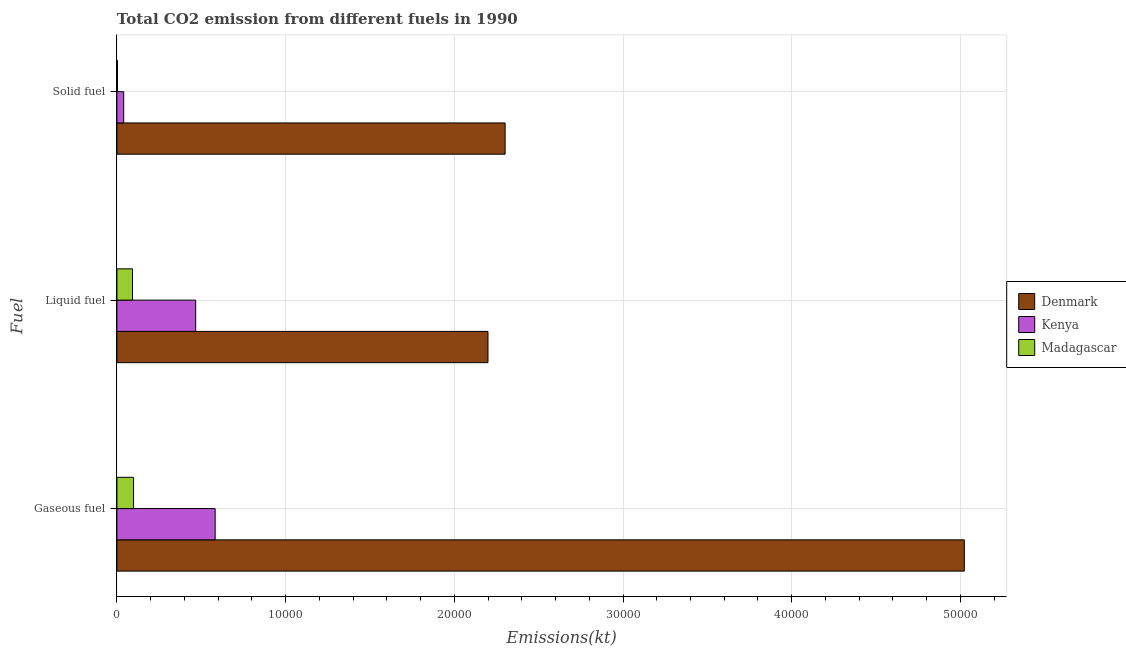How many groups of bars are there?
Your answer should be compact. 3. Are the number of bars on each tick of the Y-axis equal?
Give a very brief answer. Yes. How many bars are there on the 3rd tick from the top?
Your response must be concise. 3. What is the label of the 2nd group of bars from the top?
Make the answer very short. Liquid fuel. What is the amount of co2 emissions from liquid fuel in Madagascar?
Ensure brevity in your answer.  924.08. Across all countries, what is the maximum amount of co2 emissions from solid fuel?
Offer a very short reply. 2.30e+04. Across all countries, what is the minimum amount of co2 emissions from gaseous fuel?
Give a very brief answer. 986.42. In which country was the amount of co2 emissions from solid fuel maximum?
Your answer should be compact. Denmark. In which country was the amount of co2 emissions from solid fuel minimum?
Make the answer very short. Madagascar. What is the total amount of co2 emissions from solid fuel in the graph?
Make the answer very short. 2.34e+04. What is the difference between the amount of co2 emissions from solid fuel in Kenya and that in Denmark?
Provide a short and direct response. -2.26e+04. What is the difference between the amount of co2 emissions from liquid fuel in Madagascar and the amount of co2 emissions from gaseous fuel in Kenya?
Your answer should be very brief. -4899.11. What is the average amount of co2 emissions from gaseous fuel per country?
Your response must be concise. 1.90e+04. What is the difference between the amount of co2 emissions from solid fuel and amount of co2 emissions from liquid fuel in Denmark?
Ensure brevity in your answer.  1015.76. In how many countries, is the amount of co2 emissions from solid fuel greater than 40000 kt?
Your answer should be compact. 0. What is the ratio of the amount of co2 emissions from liquid fuel in Madagascar to that in Kenya?
Make the answer very short. 0.2. Is the amount of co2 emissions from liquid fuel in Madagascar less than that in Denmark?
Your answer should be very brief. Yes. What is the difference between the highest and the second highest amount of co2 emissions from gaseous fuel?
Your answer should be very brief. 4.44e+04. What is the difference between the highest and the lowest amount of co2 emissions from gaseous fuel?
Ensure brevity in your answer.  4.92e+04. What does the 2nd bar from the top in Liquid fuel represents?
Give a very brief answer. Kenya. What does the 2nd bar from the bottom in Liquid fuel represents?
Provide a succinct answer. Kenya. Is it the case that in every country, the sum of the amount of co2 emissions from gaseous fuel and amount of co2 emissions from liquid fuel is greater than the amount of co2 emissions from solid fuel?
Provide a succinct answer. Yes. Are the values on the major ticks of X-axis written in scientific E-notation?
Make the answer very short. No. Does the graph contain grids?
Your response must be concise. Yes. Where does the legend appear in the graph?
Ensure brevity in your answer.  Center right. How many legend labels are there?
Offer a very short reply. 3. What is the title of the graph?
Provide a short and direct response. Total CO2 emission from different fuels in 1990. What is the label or title of the X-axis?
Your answer should be very brief. Emissions(kt). What is the label or title of the Y-axis?
Offer a terse response. Fuel. What is the Emissions(kt) in Denmark in Gaseous fuel?
Your answer should be very brief. 5.02e+04. What is the Emissions(kt) in Kenya in Gaseous fuel?
Give a very brief answer. 5823.2. What is the Emissions(kt) in Madagascar in Gaseous fuel?
Offer a terse response. 986.42. What is the Emissions(kt) in Denmark in Liquid fuel?
Make the answer very short. 2.20e+04. What is the Emissions(kt) in Kenya in Liquid fuel?
Make the answer very short. 4668.09. What is the Emissions(kt) in Madagascar in Liquid fuel?
Make the answer very short. 924.08. What is the Emissions(kt) of Denmark in Solid fuel?
Offer a very short reply. 2.30e+04. What is the Emissions(kt) in Kenya in Solid fuel?
Offer a very short reply. 403.37. What is the Emissions(kt) in Madagascar in Solid fuel?
Provide a short and direct response. 33. Across all Fuel, what is the maximum Emissions(kt) in Denmark?
Keep it short and to the point. 5.02e+04. Across all Fuel, what is the maximum Emissions(kt) of Kenya?
Offer a very short reply. 5823.2. Across all Fuel, what is the maximum Emissions(kt) in Madagascar?
Your answer should be compact. 986.42. Across all Fuel, what is the minimum Emissions(kt) of Denmark?
Offer a terse response. 2.20e+04. Across all Fuel, what is the minimum Emissions(kt) of Kenya?
Your answer should be very brief. 403.37. Across all Fuel, what is the minimum Emissions(kt) of Madagascar?
Provide a short and direct response. 33. What is the total Emissions(kt) in Denmark in the graph?
Your answer should be compact. 9.52e+04. What is the total Emissions(kt) in Kenya in the graph?
Your answer should be very brief. 1.09e+04. What is the total Emissions(kt) of Madagascar in the graph?
Provide a short and direct response. 1943.51. What is the difference between the Emissions(kt) of Denmark in Gaseous fuel and that in Liquid fuel?
Your answer should be very brief. 2.82e+04. What is the difference between the Emissions(kt) in Kenya in Gaseous fuel and that in Liquid fuel?
Make the answer very short. 1155.11. What is the difference between the Emissions(kt) of Madagascar in Gaseous fuel and that in Liquid fuel?
Offer a terse response. 62.34. What is the difference between the Emissions(kt) of Denmark in Gaseous fuel and that in Solid fuel?
Offer a terse response. 2.72e+04. What is the difference between the Emissions(kt) in Kenya in Gaseous fuel and that in Solid fuel?
Keep it short and to the point. 5419.83. What is the difference between the Emissions(kt) in Madagascar in Gaseous fuel and that in Solid fuel?
Keep it short and to the point. 953.42. What is the difference between the Emissions(kt) of Denmark in Liquid fuel and that in Solid fuel?
Your answer should be very brief. -1015.76. What is the difference between the Emissions(kt) in Kenya in Liquid fuel and that in Solid fuel?
Make the answer very short. 4264.72. What is the difference between the Emissions(kt) in Madagascar in Liquid fuel and that in Solid fuel?
Your answer should be compact. 891.08. What is the difference between the Emissions(kt) of Denmark in Gaseous fuel and the Emissions(kt) of Kenya in Liquid fuel?
Give a very brief answer. 4.56e+04. What is the difference between the Emissions(kt) of Denmark in Gaseous fuel and the Emissions(kt) of Madagascar in Liquid fuel?
Ensure brevity in your answer.  4.93e+04. What is the difference between the Emissions(kt) of Kenya in Gaseous fuel and the Emissions(kt) of Madagascar in Liquid fuel?
Give a very brief answer. 4899.11. What is the difference between the Emissions(kt) of Denmark in Gaseous fuel and the Emissions(kt) of Kenya in Solid fuel?
Your response must be concise. 4.98e+04. What is the difference between the Emissions(kt) of Denmark in Gaseous fuel and the Emissions(kt) of Madagascar in Solid fuel?
Your response must be concise. 5.02e+04. What is the difference between the Emissions(kt) of Kenya in Gaseous fuel and the Emissions(kt) of Madagascar in Solid fuel?
Give a very brief answer. 5790.19. What is the difference between the Emissions(kt) in Denmark in Liquid fuel and the Emissions(kt) in Kenya in Solid fuel?
Your answer should be very brief. 2.16e+04. What is the difference between the Emissions(kt) of Denmark in Liquid fuel and the Emissions(kt) of Madagascar in Solid fuel?
Your answer should be compact. 2.20e+04. What is the difference between the Emissions(kt) in Kenya in Liquid fuel and the Emissions(kt) in Madagascar in Solid fuel?
Offer a very short reply. 4635.09. What is the average Emissions(kt) in Denmark per Fuel?
Your answer should be very brief. 3.17e+04. What is the average Emissions(kt) in Kenya per Fuel?
Your answer should be very brief. 3631.55. What is the average Emissions(kt) of Madagascar per Fuel?
Keep it short and to the point. 647.84. What is the difference between the Emissions(kt) of Denmark and Emissions(kt) of Kenya in Gaseous fuel?
Provide a succinct answer. 4.44e+04. What is the difference between the Emissions(kt) of Denmark and Emissions(kt) of Madagascar in Gaseous fuel?
Make the answer very short. 4.92e+04. What is the difference between the Emissions(kt) of Kenya and Emissions(kt) of Madagascar in Gaseous fuel?
Ensure brevity in your answer.  4836.77. What is the difference between the Emissions(kt) of Denmark and Emissions(kt) of Kenya in Liquid fuel?
Keep it short and to the point. 1.73e+04. What is the difference between the Emissions(kt) in Denmark and Emissions(kt) in Madagascar in Liquid fuel?
Offer a very short reply. 2.11e+04. What is the difference between the Emissions(kt) of Kenya and Emissions(kt) of Madagascar in Liquid fuel?
Ensure brevity in your answer.  3744.01. What is the difference between the Emissions(kt) of Denmark and Emissions(kt) of Kenya in Solid fuel?
Your answer should be very brief. 2.26e+04. What is the difference between the Emissions(kt) of Denmark and Emissions(kt) of Madagascar in Solid fuel?
Your answer should be compact. 2.30e+04. What is the difference between the Emissions(kt) in Kenya and Emissions(kt) in Madagascar in Solid fuel?
Your answer should be compact. 370.37. What is the ratio of the Emissions(kt) of Denmark in Gaseous fuel to that in Liquid fuel?
Make the answer very short. 2.28. What is the ratio of the Emissions(kt) of Kenya in Gaseous fuel to that in Liquid fuel?
Make the answer very short. 1.25. What is the ratio of the Emissions(kt) of Madagascar in Gaseous fuel to that in Liquid fuel?
Keep it short and to the point. 1.07. What is the ratio of the Emissions(kt) in Denmark in Gaseous fuel to that in Solid fuel?
Offer a very short reply. 2.18. What is the ratio of the Emissions(kt) in Kenya in Gaseous fuel to that in Solid fuel?
Provide a succinct answer. 14.44. What is the ratio of the Emissions(kt) in Madagascar in Gaseous fuel to that in Solid fuel?
Offer a very short reply. 29.89. What is the ratio of the Emissions(kt) in Denmark in Liquid fuel to that in Solid fuel?
Offer a terse response. 0.96. What is the ratio of the Emissions(kt) in Kenya in Liquid fuel to that in Solid fuel?
Offer a terse response. 11.57. What is the ratio of the Emissions(kt) of Madagascar in Liquid fuel to that in Solid fuel?
Offer a terse response. 28. What is the difference between the highest and the second highest Emissions(kt) in Denmark?
Make the answer very short. 2.72e+04. What is the difference between the highest and the second highest Emissions(kt) in Kenya?
Offer a very short reply. 1155.11. What is the difference between the highest and the second highest Emissions(kt) of Madagascar?
Provide a short and direct response. 62.34. What is the difference between the highest and the lowest Emissions(kt) in Denmark?
Your answer should be compact. 2.82e+04. What is the difference between the highest and the lowest Emissions(kt) in Kenya?
Your response must be concise. 5419.83. What is the difference between the highest and the lowest Emissions(kt) in Madagascar?
Offer a terse response. 953.42. 